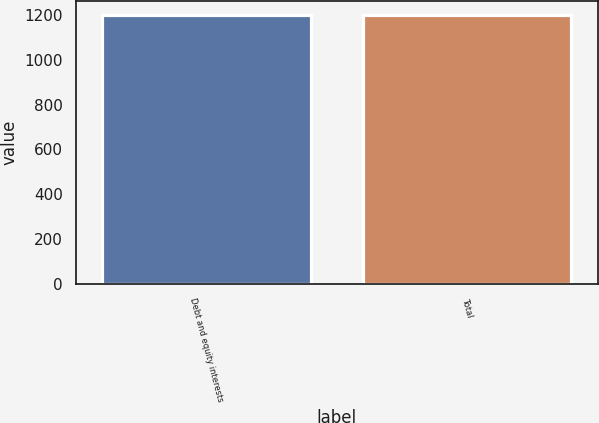Convert chart to OTSL. <chart><loc_0><loc_0><loc_500><loc_500><bar_chart><fcel>Debt and equity interests<fcel>Total<nl><fcel>1202<fcel>1202.1<nl></chart> 